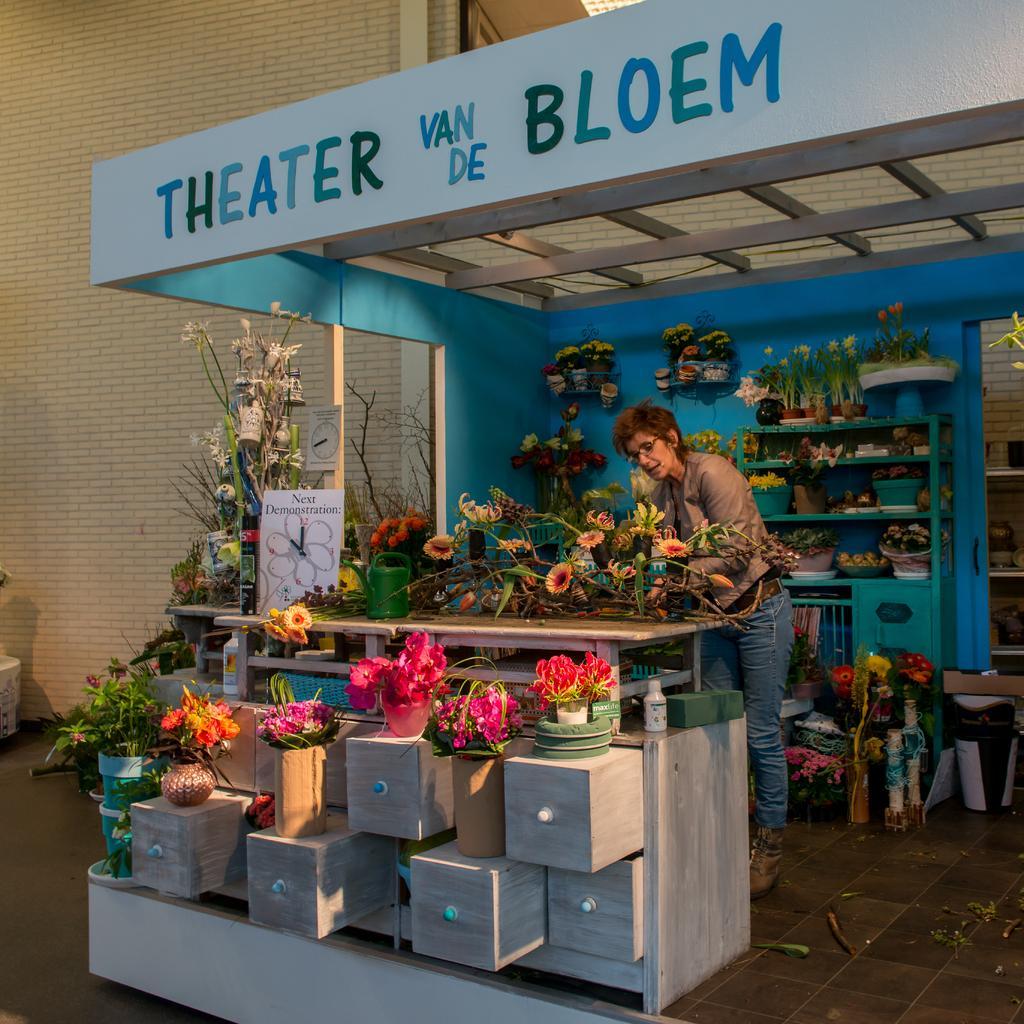Can you describe this image briefly? In this image we can see a person wearing the glasses and standing. We can see the flower pots, racks and also the building wall in the background. We can also see the path. We can see a board. 